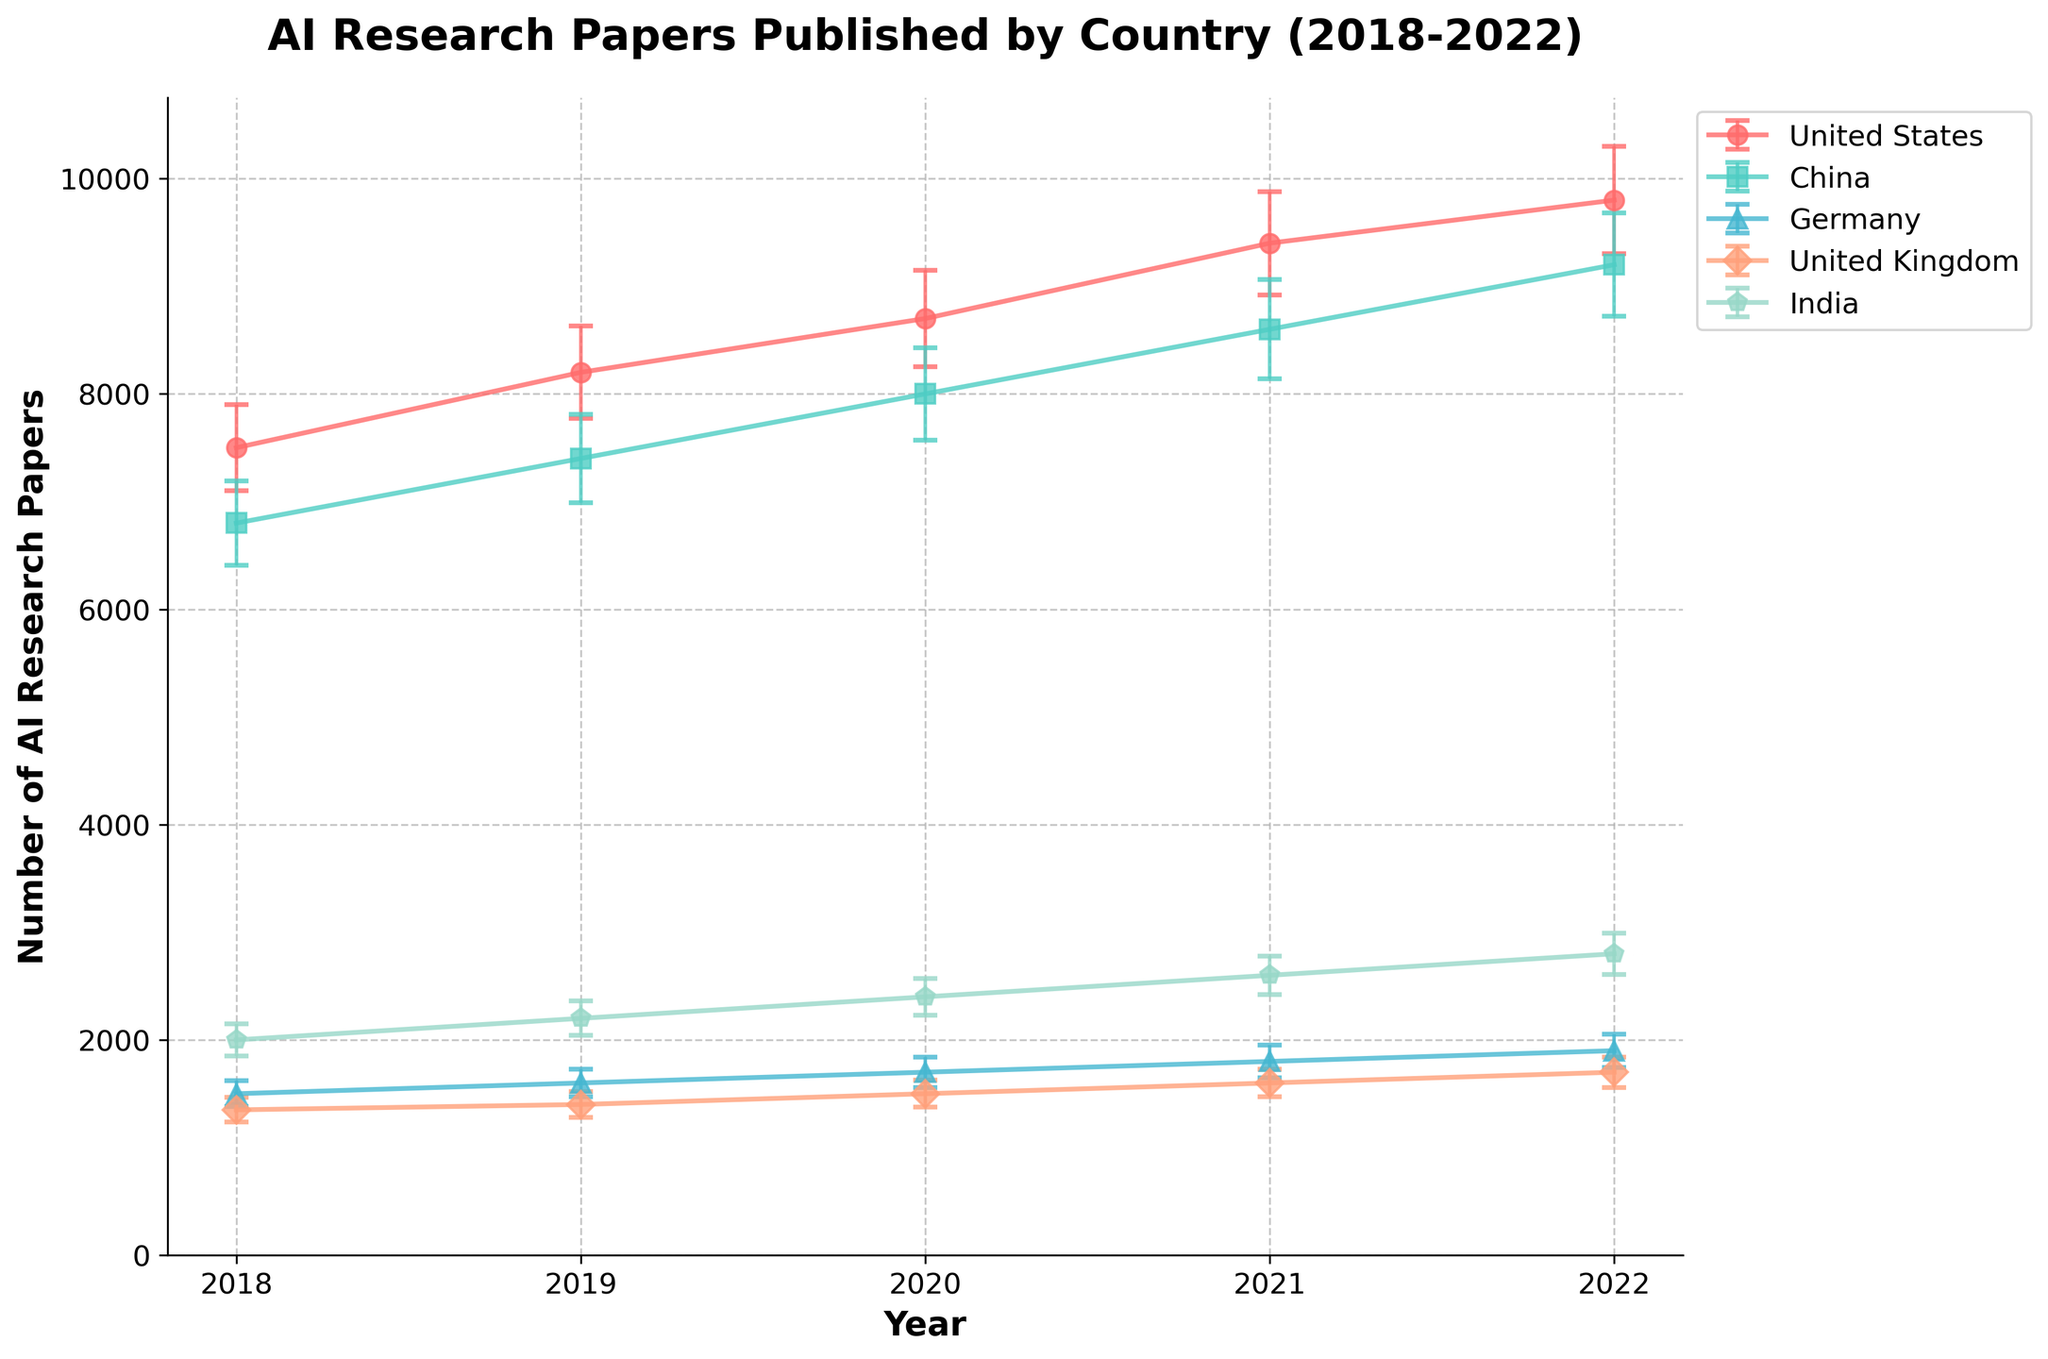What is the title of the plot? The title of the plot is located at the top of the figure and usually summarizes the main idea being conveyed by the plot.
Answer: AI Research Papers Published by Country (2018-2022) Which country had the highest number of AI research papers published in 2022? By looking at the endpoints of the 2022 data points for all countries, you can observe that the United States has the highest y-value, indicating the number of research papers.
Answer: United States What is the trend in the number of AI research papers published by China from 2018 to 2022? Observing the data points for China across the years on the x-axis, it is clear that the y-values (number of publications) are increasing every year, indicating a rising trend.
Answer: Increasing How does the number of AI research papers published by Germany compare to that of India in 2020? In 2020, Germany has a publication value of 1700 while India has a publication value of 2400. From this, it is evident India had more publications in 2020.
Answer: India had more publications Which country had the smallest standard deviation in 2020, indicating more consistency in their AI research paper publications that year? By checking the error bars (indicating standard deviations) for the year 2020, Germany has the smallest error bar compared to other countries.
Answer: Germany Calculate the average number of AI research papers published by the United States over the five years presented. Add the yearly publications (7500 + 8200 + 8700 + 9400 + 9800) and divide by 5. The calculation is: (7500 + 8200 + 8700 + 9400 + 9800) / 5 = 8720.
Answer: 8720 Of the countries listed, which one showed the most growth in the number of AI publications from 2018 to 2022? Compute the difference in the number of publications between 2018 and 2022 for each country. The increase for the United States is (9800 - 7500 = 2300), for China is (9200 - 6800 = 2400), for Germany is (1900 - 1500 = 400), for the United Kingdom is (1700 - 1350 = 350), and for India is (2800 - 2000 = 800). China showed the biggest increase.
Answer: China What is the color of the line representing the United States in the plot? The color of each line can be recognized by matching the legend entries with the lines. The line for the United States is the first entry and is red.
Answer: Red Is the number of AI research papers published by the United Kingdom increasing or decreasing over the period 2018-2022? By observing the data points of the United Kingdom, it can be seen that the y-values increase consistently across the years, implying an increasing trend.
Answer: Increasing 